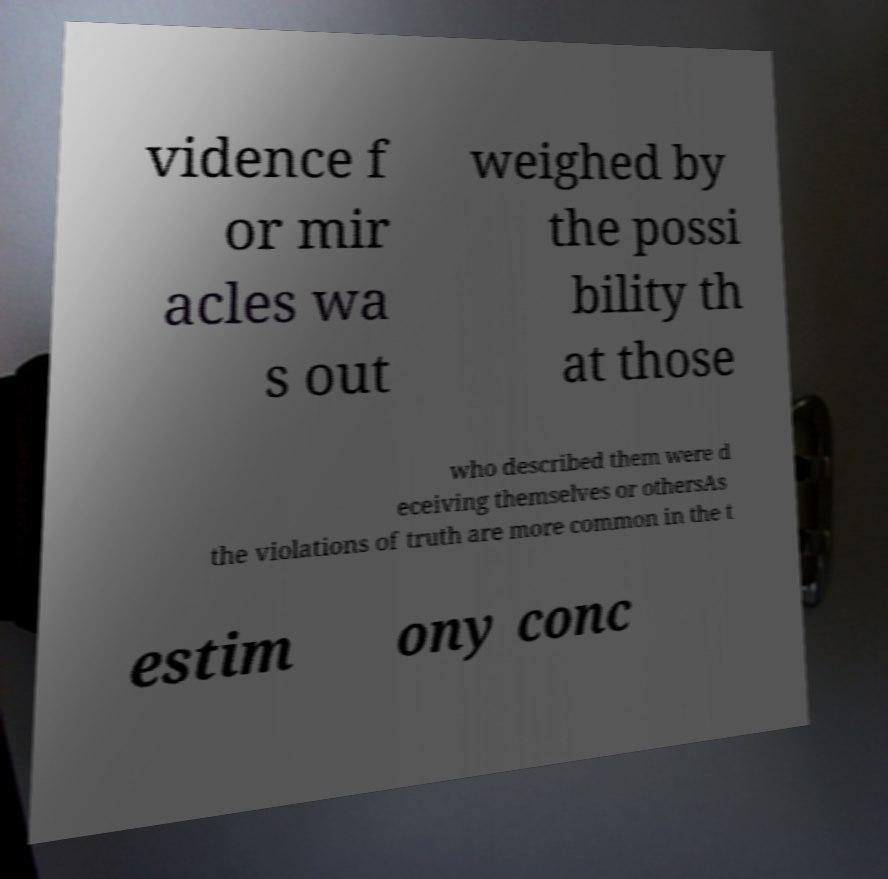Please identify and transcribe the text found in this image. vidence f or mir acles wa s out weighed by the possi bility th at those who described them were d eceiving themselves or othersAs the violations of truth are more common in the t estim ony conc 